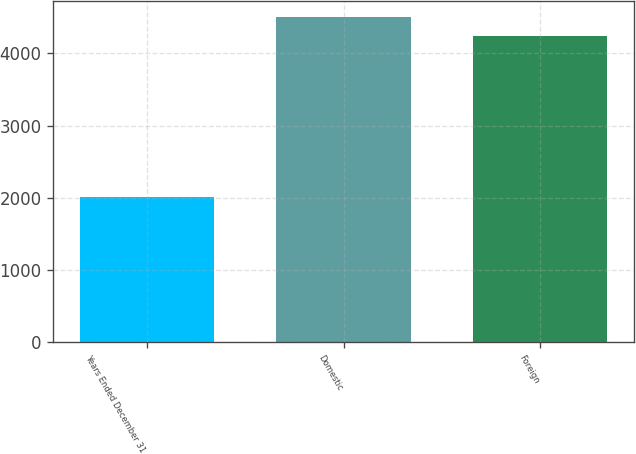Convert chart to OTSL. <chart><loc_0><loc_0><loc_500><loc_500><bar_chart><fcel>Years Ended December 31<fcel>Domestic<fcel>Foreign<nl><fcel>2012<fcel>4500<fcel>4239<nl></chart> 